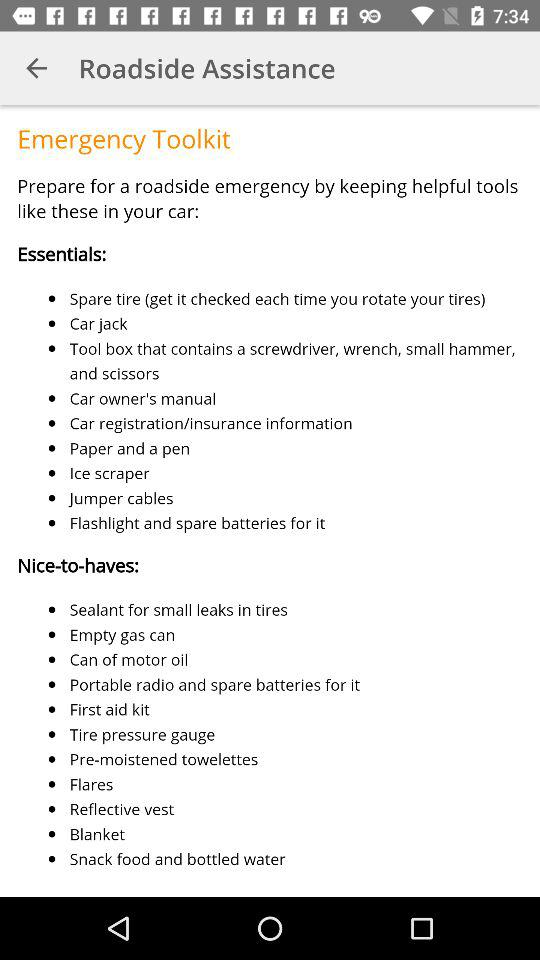Which list contains "Jumper cables"?
Answer the question using a single word or phrase. It is listed under "Essentials." 